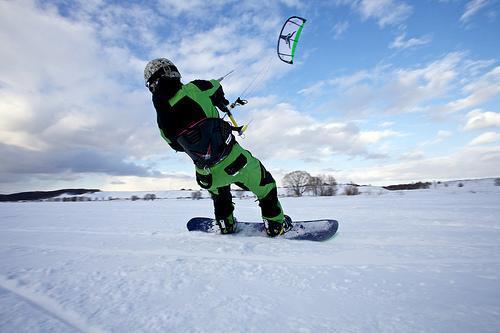How many snowboarders are there?
Give a very brief answer. 1. 